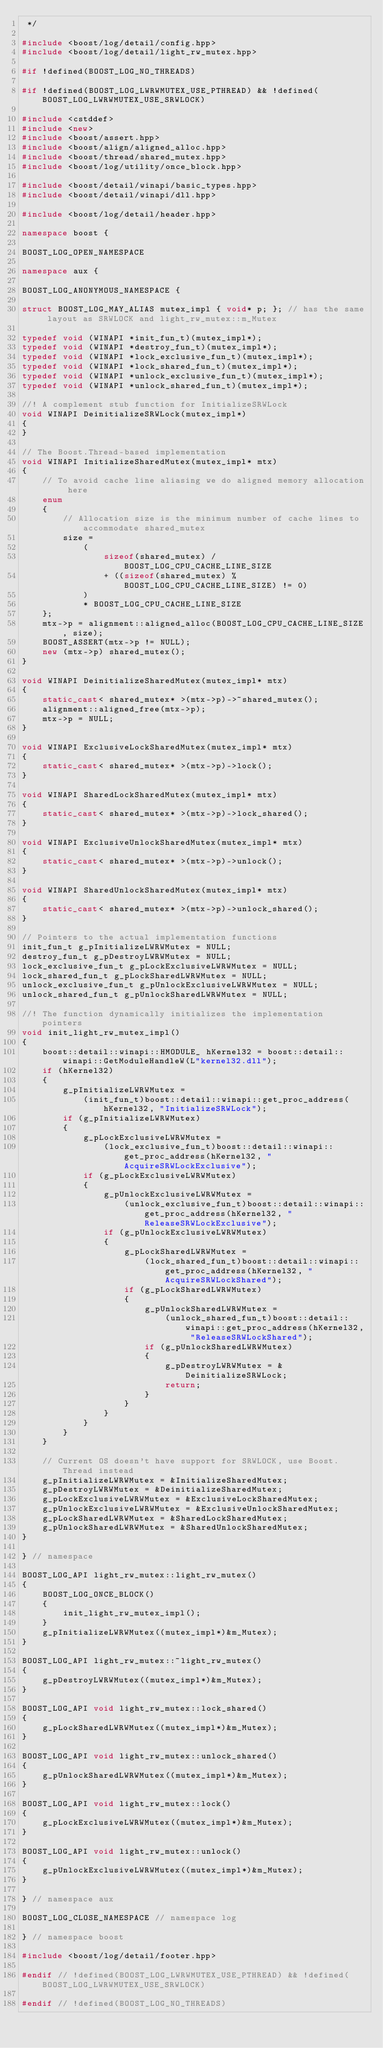Convert code to text. <code><loc_0><loc_0><loc_500><loc_500><_C++_> */

#include <boost/log/detail/config.hpp>
#include <boost/log/detail/light_rw_mutex.hpp>

#if !defined(BOOST_LOG_NO_THREADS)

#if !defined(BOOST_LOG_LWRWMUTEX_USE_PTHREAD) && !defined(BOOST_LOG_LWRWMUTEX_USE_SRWLOCK)

#include <cstddef>
#include <new>
#include <boost/assert.hpp>
#include <boost/align/aligned_alloc.hpp>
#include <boost/thread/shared_mutex.hpp>
#include <boost/log/utility/once_block.hpp>

#include <boost/detail/winapi/basic_types.hpp>
#include <boost/detail/winapi/dll.hpp>

#include <boost/log/detail/header.hpp>

namespace boost {

BOOST_LOG_OPEN_NAMESPACE

namespace aux {

BOOST_LOG_ANONYMOUS_NAMESPACE {

struct BOOST_LOG_MAY_ALIAS mutex_impl { void* p; }; // has the same layout as SRWLOCK and light_rw_mutex::m_Mutex

typedef void (WINAPI *init_fun_t)(mutex_impl*);
typedef void (WINAPI *destroy_fun_t)(mutex_impl*);
typedef void (WINAPI *lock_exclusive_fun_t)(mutex_impl*);
typedef void (WINAPI *lock_shared_fun_t)(mutex_impl*);
typedef void (WINAPI *unlock_exclusive_fun_t)(mutex_impl*);
typedef void (WINAPI *unlock_shared_fun_t)(mutex_impl*);

//! A complement stub function for InitializeSRWLock
void WINAPI DeinitializeSRWLock(mutex_impl*)
{
}

// The Boost.Thread-based implementation
void WINAPI InitializeSharedMutex(mutex_impl* mtx)
{
    // To avoid cache line aliasing we do aligned memory allocation here
    enum
    {
        // Allocation size is the minimum number of cache lines to accommodate shared_mutex
        size =
            (
                sizeof(shared_mutex) / BOOST_LOG_CPU_CACHE_LINE_SIZE
                + ((sizeof(shared_mutex) % BOOST_LOG_CPU_CACHE_LINE_SIZE) != 0)
            )
            * BOOST_LOG_CPU_CACHE_LINE_SIZE
    };
    mtx->p = alignment::aligned_alloc(BOOST_LOG_CPU_CACHE_LINE_SIZE, size);
    BOOST_ASSERT(mtx->p != NULL);
    new (mtx->p) shared_mutex();
}

void WINAPI DeinitializeSharedMutex(mutex_impl* mtx)
{
    static_cast< shared_mutex* >(mtx->p)->~shared_mutex();
    alignment::aligned_free(mtx->p);
    mtx->p = NULL;
}

void WINAPI ExclusiveLockSharedMutex(mutex_impl* mtx)
{
    static_cast< shared_mutex* >(mtx->p)->lock();
}

void WINAPI SharedLockSharedMutex(mutex_impl* mtx)
{
    static_cast< shared_mutex* >(mtx->p)->lock_shared();
}

void WINAPI ExclusiveUnlockSharedMutex(mutex_impl* mtx)
{
    static_cast< shared_mutex* >(mtx->p)->unlock();
}

void WINAPI SharedUnlockSharedMutex(mutex_impl* mtx)
{
    static_cast< shared_mutex* >(mtx->p)->unlock_shared();
}

// Pointers to the actual implementation functions
init_fun_t g_pInitializeLWRWMutex = NULL;
destroy_fun_t g_pDestroyLWRWMutex = NULL;
lock_exclusive_fun_t g_pLockExclusiveLWRWMutex = NULL;
lock_shared_fun_t g_pLockSharedLWRWMutex = NULL;
unlock_exclusive_fun_t g_pUnlockExclusiveLWRWMutex = NULL;
unlock_shared_fun_t g_pUnlockSharedLWRWMutex = NULL;

//! The function dynamically initializes the implementation pointers
void init_light_rw_mutex_impl()
{
    boost::detail::winapi::HMODULE_ hKernel32 = boost::detail::winapi::GetModuleHandleW(L"kernel32.dll");
    if (hKernel32)
    {
        g_pInitializeLWRWMutex =
            (init_fun_t)boost::detail::winapi::get_proc_address(hKernel32, "InitializeSRWLock");
        if (g_pInitializeLWRWMutex)
        {
            g_pLockExclusiveLWRWMutex =
                (lock_exclusive_fun_t)boost::detail::winapi::get_proc_address(hKernel32, "AcquireSRWLockExclusive");
            if (g_pLockExclusiveLWRWMutex)
            {
                g_pUnlockExclusiveLWRWMutex =
                    (unlock_exclusive_fun_t)boost::detail::winapi::get_proc_address(hKernel32, "ReleaseSRWLockExclusive");
                if (g_pUnlockExclusiveLWRWMutex)
                {
                    g_pLockSharedLWRWMutex =
                        (lock_shared_fun_t)boost::detail::winapi::get_proc_address(hKernel32, "AcquireSRWLockShared");
                    if (g_pLockSharedLWRWMutex)
                    {
                        g_pUnlockSharedLWRWMutex =
                            (unlock_shared_fun_t)boost::detail::winapi::get_proc_address(hKernel32, "ReleaseSRWLockShared");
                        if (g_pUnlockSharedLWRWMutex)
                        {
                            g_pDestroyLWRWMutex = &DeinitializeSRWLock;
                            return;
                        }
                    }
                }
            }
        }
    }

    // Current OS doesn't have support for SRWLOCK, use Boost.Thread instead
    g_pInitializeLWRWMutex = &InitializeSharedMutex;
    g_pDestroyLWRWMutex = &DeinitializeSharedMutex;
    g_pLockExclusiveLWRWMutex = &ExclusiveLockSharedMutex;
    g_pUnlockExclusiveLWRWMutex = &ExclusiveUnlockSharedMutex;
    g_pLockSharedLWRWMutex = &SharedLockSharedMutex;
    g_pUnlockSharedLWRWMutex = &SharedUnlockSharedMutex;
}

} // namespace

BOOST_LOG_API light_rw_mutex::light_rw_mutex()
{
    BOOST_LOG_ONCE_BLOCK()
    {
        init_light_rw_mutex_impl();
    }
    g_pInitializeLWRWMutex((mutex_impl*)&m_Mutex);
}

BOOST_LOG_API light_rw_mutex::~light_rw_mutex()
{
    g_pDestroyLWRWMutex((mutex_impl*)&m_Mutex);
}

BOOST_LOG_API void light_rw_mutex::lock_shared()
{
    g_pLockSharedLWRWMutex((mutex_impl*)&m_Mutex);
}

BOOST_LOG_API void light_rw_mutex::unlock_shared()
{
    g_pUnlockSharedLWRWMutex((mutex_impl*)&m_Mutex);
}

BOOST_LOG_API void light_rw_mutex::lock()
{
    g_pLockExclusiveLWRWMutex((mutex_impl*)&m_Mutex);
}

BOOST_LOG_API void light_rw_mutex::unlock()
{
    g_pUnlockExclusiveLWRWMutex((mutex_impl*)&m_Mutex);
}

} // namespace aux

BOOST_LOG_CLOSE_NAMESPACE // namespace log

} // namespace boost

#include <boost/log/detail/footer.hpp>

#endif // !defined(BOOST_LOG_LWRWMUTEX_USE_PTHREAD) && !defined(BOOST_LOG_LWRWMUTEX_USE_SRWLOCK)

#endif // !defined(BOOST_LOG_NO_THREADS)
</code> 